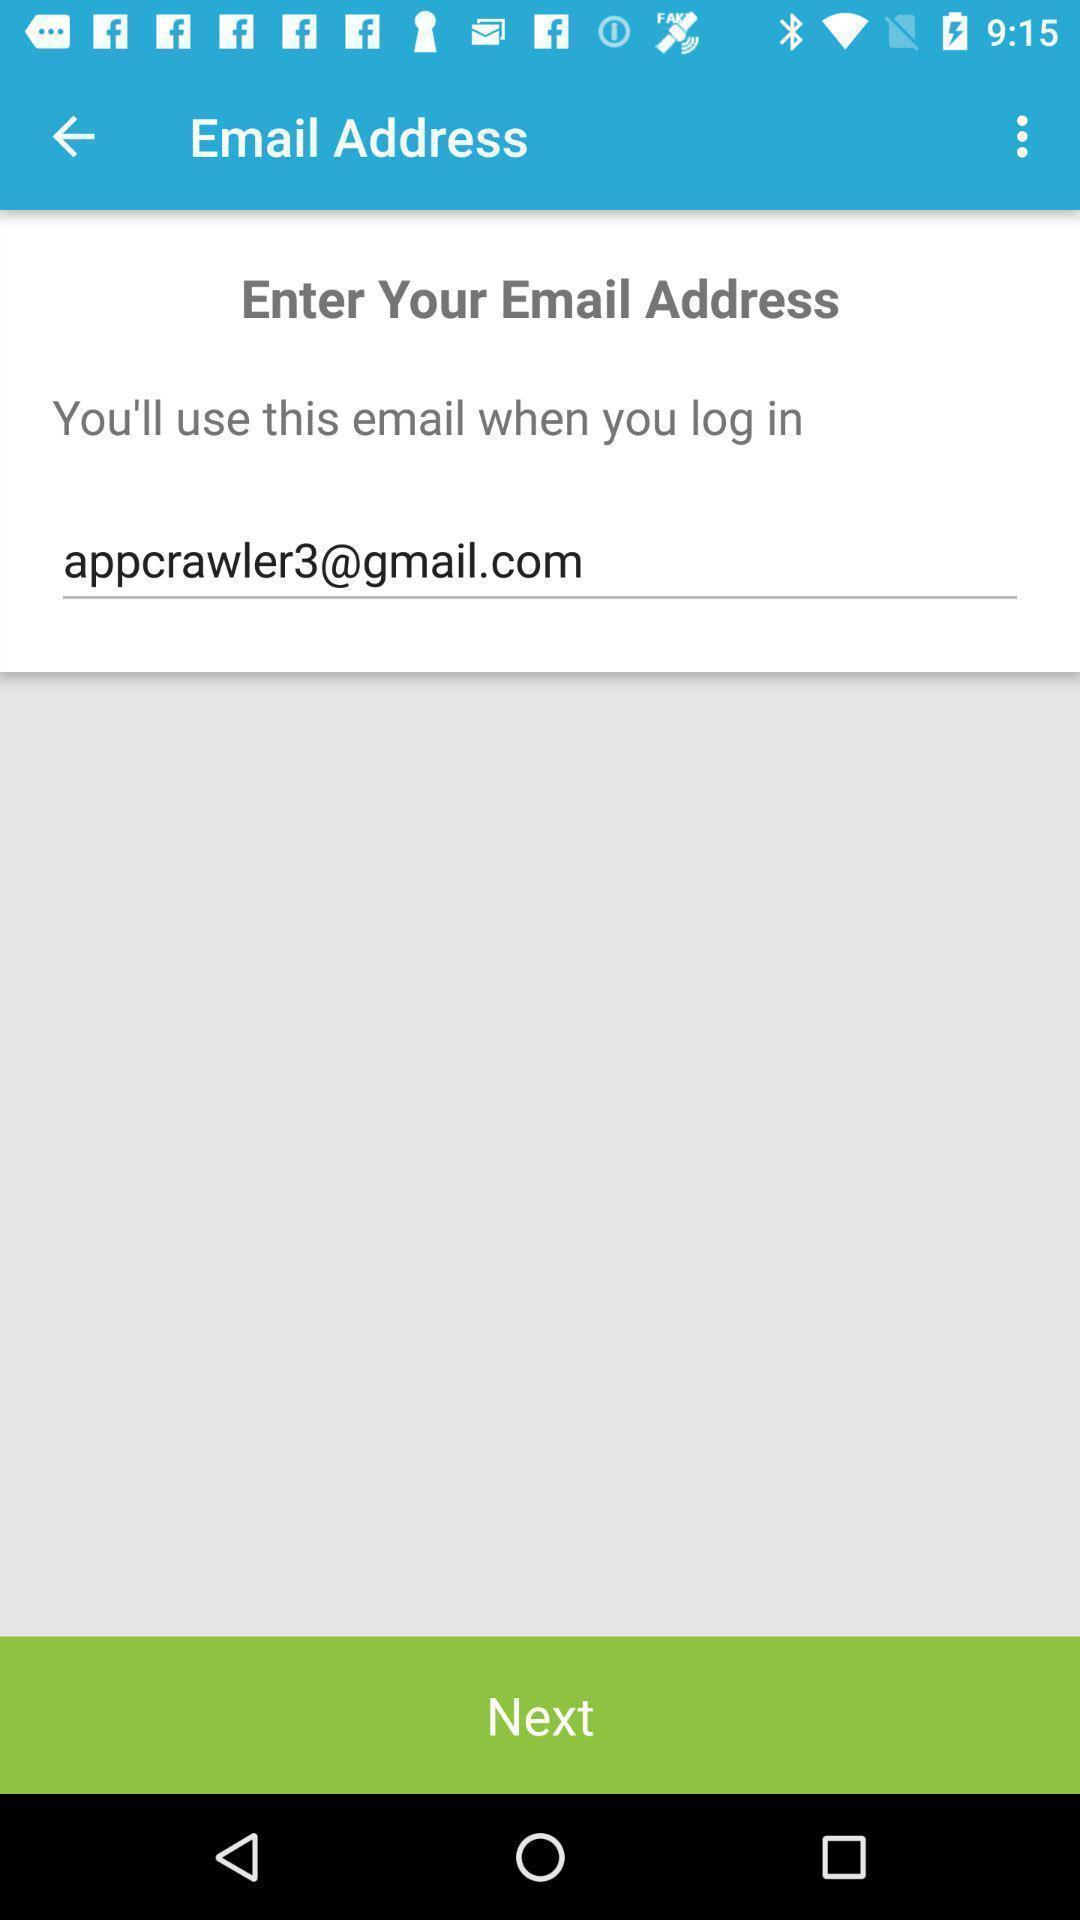Provide a detailed account of this screenshot. Screen displaying to log in by using email address. 